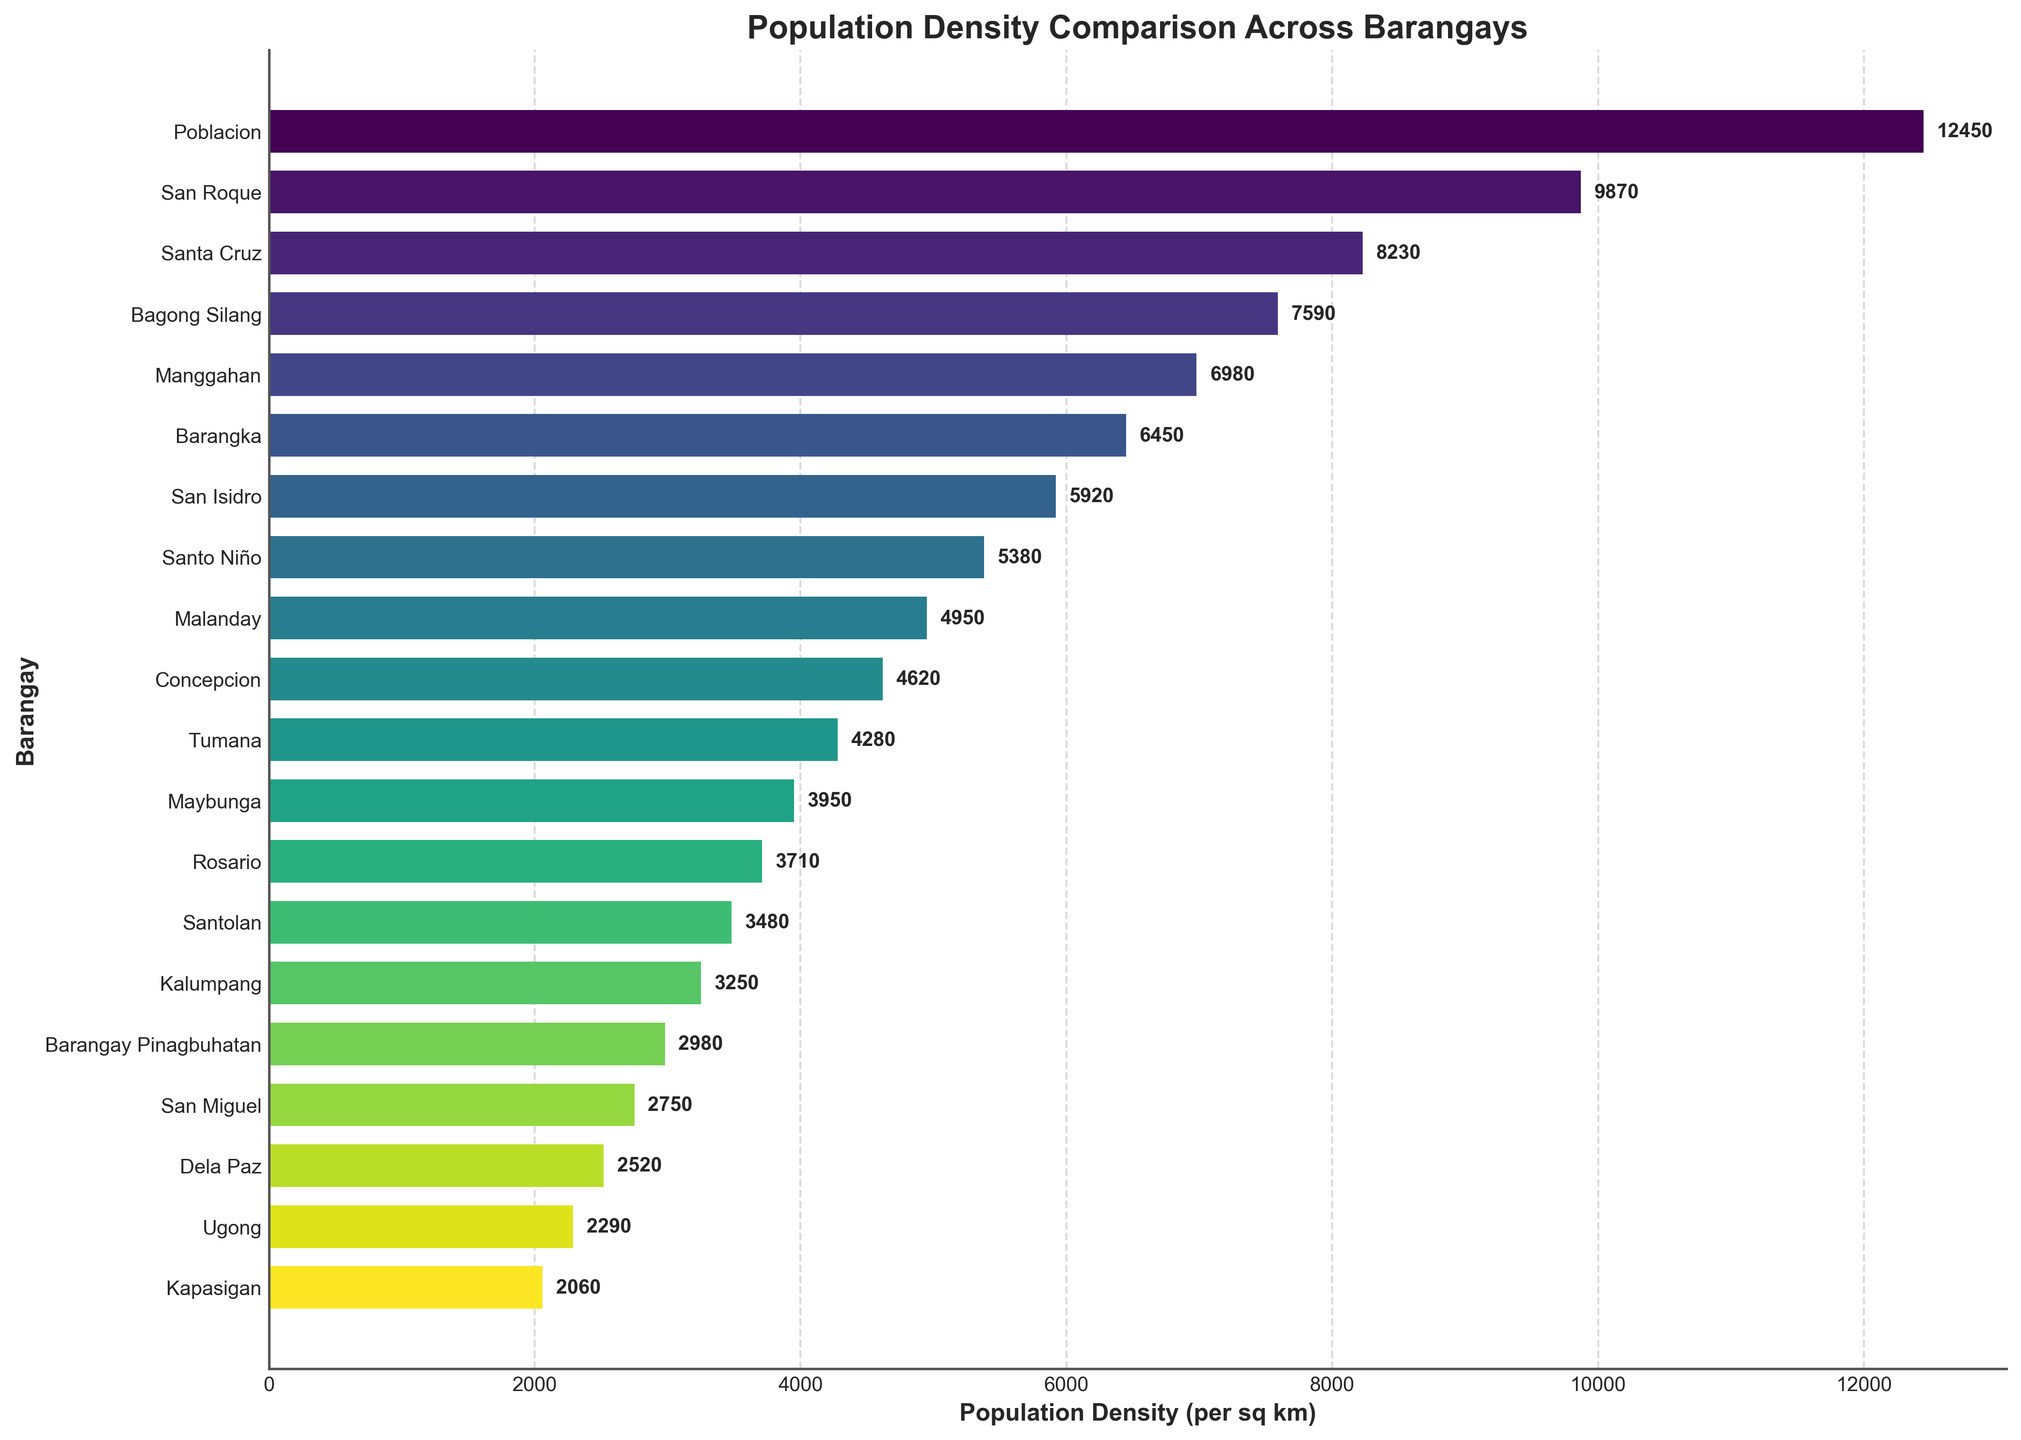Which barangay has the highest population density? To identify the barangay with the highest population density, locate the tallest bar in the plot and check its corresponding label.
Answer: Poblacion Which barangay has the lowest population density? Find the shortest bar in the plot and look at the label associated with it.
Answer: Kapasigan What is the difference in population density between Poblacion and Kapasigan? Poblacion has a population density of 12,450 per sq km, while Kapasigan has 2,060 per sq km. The difference is calculated as 12,450 - 2,060.
Answer: 10,390 Which barangay has a population density closest to 5,000 per sq km? Identify the bar that represents a population density near 5,000 by locating values around the 5,000 mark.
Answer: Malanday List the barangays with a population density greater than 7,000 per sq km. Identify all bars with lengths exceeding 7,000 and note their corresponding labels.
Answer: Poblacion, San Roque, Santa Cruz, Bagong Silang, Manggahan What is the average population density of the barangays with a population density less than 4,000 per sq km? Identify barangays with densities below 4,000: Kapasigan (2,060), Ugong (2,290), Dela Paz (2,520), San Miguel (2,750), Barangay Pinagbuhatan (2,980), Kalumpang (3,250), Santolan (3,480), Rosario (3,710), Maybunga (3,950). Sum these values and divide by the count (9). The sum is 26,990 and average is 26,990 / 9.
Answer: 2,998.89 What is the combined population density of San Roque and Santo Niño? San Roque has a population density of 9,870 per sq km and Santo Niño has 5,380 per sq km. Add these two values to get the combined density.
Answer: 15,250 Are there more barangays with a population density greater than 6,000 per sq km or less than 6,000 per sq km? Count the number of bars above and below the 6,000 mark. There are 6 barangays above and 13 below.
Answer: Less than 6,000 Among Manggahan, Barangka, and Malanday, which barangay has the highest population density? Compare the bars representing these three barangays to determine which one is the tallest.
Answer: Manggahan What is the population density range (difference between the highest and lowest density) among all barangays? Subtract the lowest population density (Kapasigan, 2,060 per sq km) from the highest (Poblacion, 12,450 per sq km) to find the range.
Answer: 10,390 